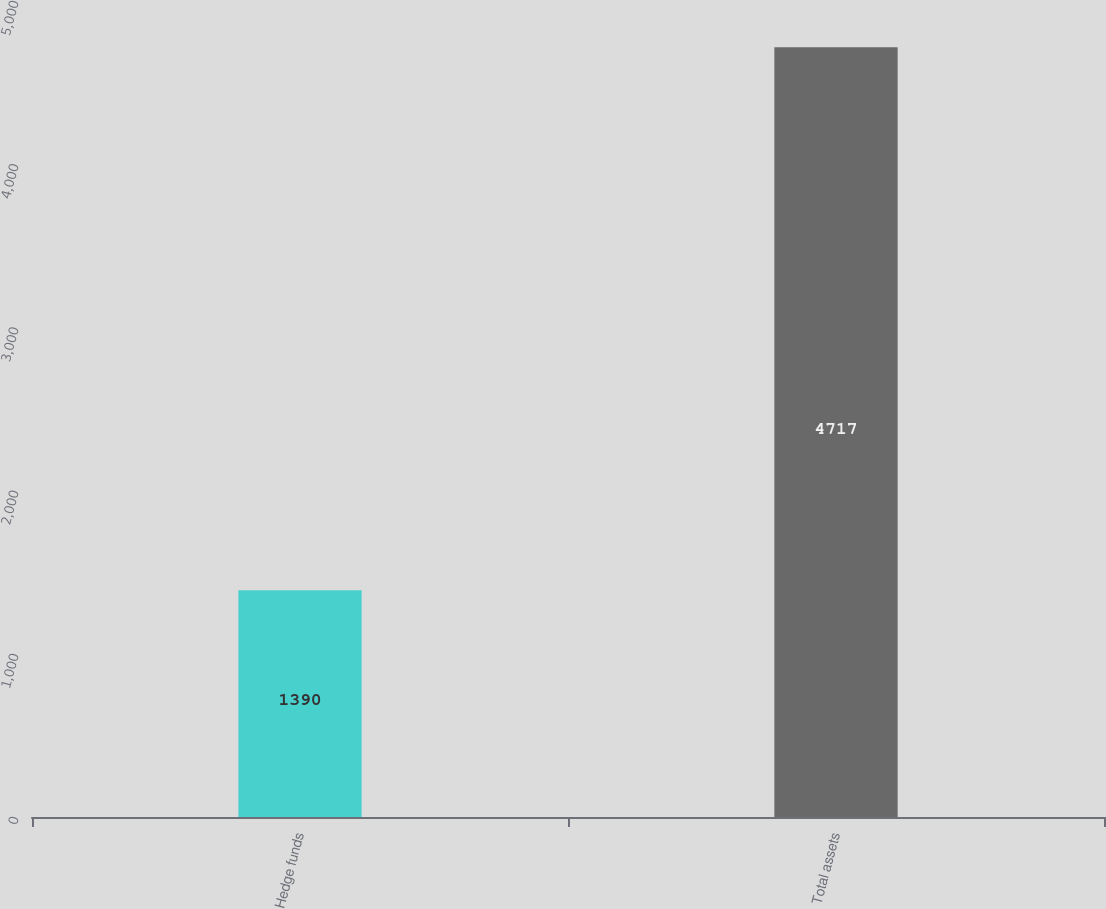<chart> <loc_0><loc_0><loc_500><loc_500><bar_chart><fcel>Hedge funds<fcel>Total assets<nl><fcel>1390<fcel>4717<nl></chart> 